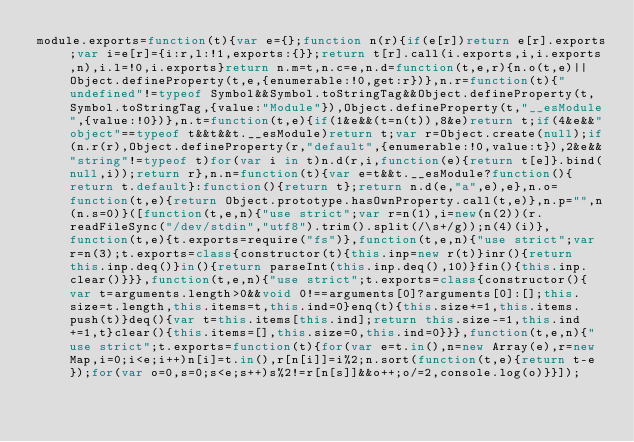<code> <loc_0><loc_0><loc_500><loc_500><_JavaScript_>module.exports=function(t){var e={};function n(r){if(e[r])return e[r].exports;var i=e[r]={i:r,l:!1,exports:{}};return t[r].call(i.exports,i,i.exports,n),i.l=!0,i.exports}return n.m=t,n.c=e,n.d=function(t,e,r){n.o(t,e)||Object.defineProperty(t,e,{enumerable:!0,get:r})},n.r=function(t){"undefined"!=typeof Symbol&&Symbol.toStringTag&&Object.defineProperty(t,Symbol.toStringTag,{value:"Module"}),Object.defineProperty(t,"__esModule",{value:!0})},n.t=function(t,e){if(1&e&&(t=n(t)),8&e)return t;if(4&e&&"object"==typeof t&&t&&t.__esModule)return t;var r=Object.create(null);if(n.r(r),Object.defineProperty(r,"default",{enumerable:!0,value:t}),2&e&&"string"!=typeof t)for(var i in t)n.d(r,i,function(e){return t[e]}.bind(null,i));return r},n.n=function(t){var e=t&&t.__esModule?function(){return t.default}:function(){return t};return n.d(e,"a",e),e},n.o=function(t,e){return Object.prototype.hasOwnProperty.call(t,e)},n.p="",n(n.s=0)}([function(t,e,n){"use strict";var r=n(1),i=new(n(2))(r.readFileSync("/dev/stdin","utf8").trim().split(/\s+/g));n(4)(i)},function(t,e){t.exports=require("fs")},function(t,e,n){"use strict";var r=n(3);t.exports=class{constructor(t){this.inp=new r(t)}inr(){return this.inp.deq()}in(){return parseInt(this.inp.deq(),10)}fin(){this.inp.clear()}}},function(t,e,n){"use strict";t.exports=class{constructor(){var t=arguments.length>0&&void 0!==arguments[0]?arguments[0]:[];this.size=t.length,this.items=t,this.ind=0}enq(t){this.size+=1,this.items.push(t)}deq(){var t=this.items[this.ind];return this.size-=1,this.ind+=1,t}clear(){this.items=[],this.size=0,this.ind=0}}},function(t,e,n){"use strict";t.exports=function(t){for(var e=t.in(),n=new Array(e),r=new Map,i=0;i<e;i++)n[i]=t.in(),r[n[i]]=i%2;n.sort(function(t,e){return t-e});for(var o=0,s=0;s<e;s++)s%2!=r[n[s]]&&o++;o/=2,console.log(o)}}]);</code> 